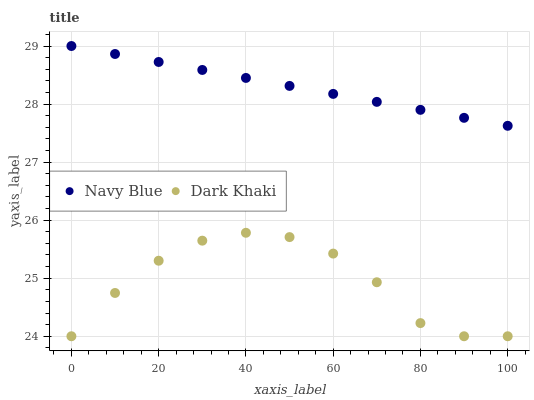Does Dark Khaki have the minimum area under the curve?
Answer yes or no. Yes. Does Navy Blue have the maximum area under the curve?
Answer yes or no. Yes. Does Navy Blue have the minimum area under the curve?
Answer yes or no. No. Is Navy Blue the smoothest?
Answer yes or no. Yes. Is Dark Khaki the roughest?
Answer yes or no. Yes. Is Navy Blue the roughest?
Answer yes or no. No. Does Dark Khaki have the lowest value?
Answer yes or no. Yes. Does Navy Blue have the lowest value?
Answer yes or no. No. Does Navy Blue have the highest value?
Answer yes or no. Yes. Is Dark Khaki less than Navy Blue?
Answer yes or no. Yes. Is Navy Blue greater than Dark Khaki?
Answer yes or no. Yes. Does Dark Khaki intersect Navy Blue?
Answer yes or no. No. 